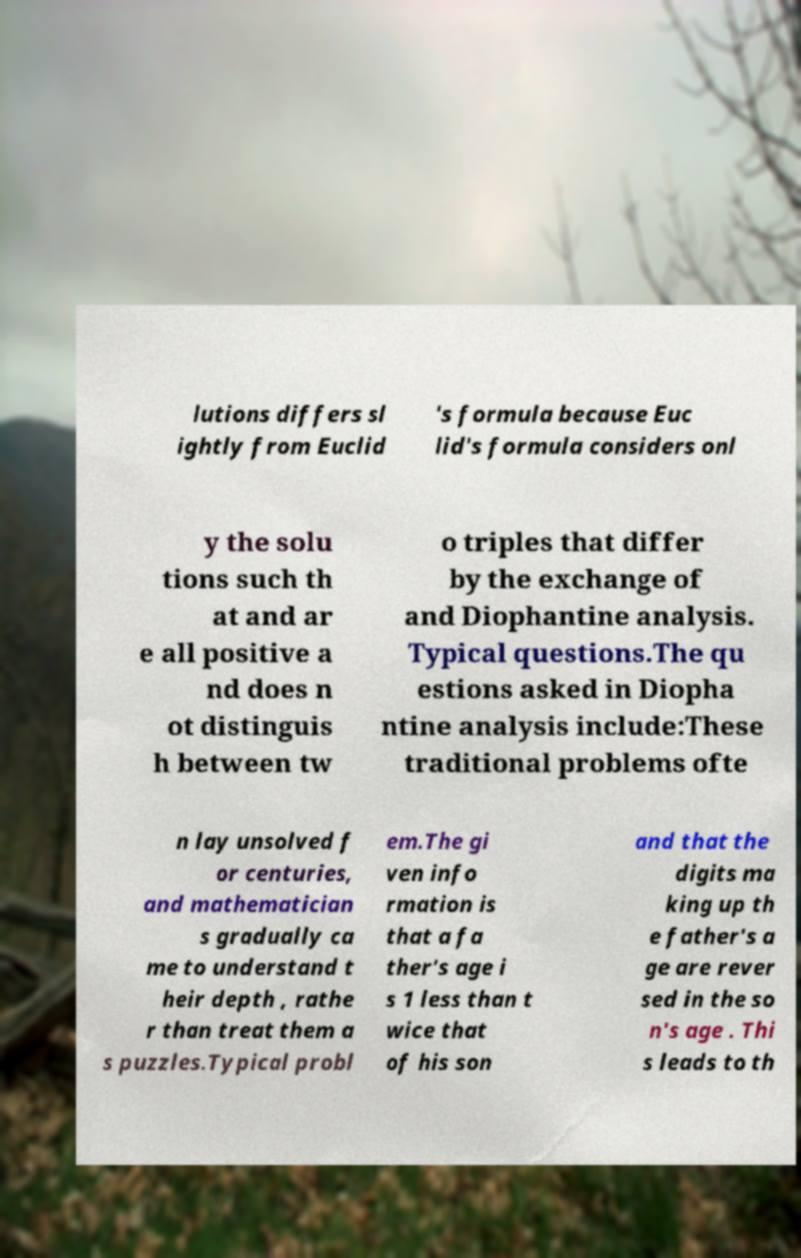Can you accurately transcribe the text from the provided image for me? lutions differs sl ightly from Euclid 's formula because Euc lid's formula considers onl y the solu tions such th at and ar e all positive a nd does n ot distinguis h between tw o triples that differ by the exchange of and Diophantine analysis. Typical questions.The qu estions asked in Diopha ntine analysis include:These traditional problems ofte n lay unsolved f or centuries, and mathematician s gradually ca me to understand t heir depth , rathe r than treat them a s puzzles.Typical probl em.The gi ven info rmation is that a fa ther's age i s 1 less than t wice that of his son and that the digits ma king up th e father's a ge are rever sed in the so n's age . Thi s leads to th 